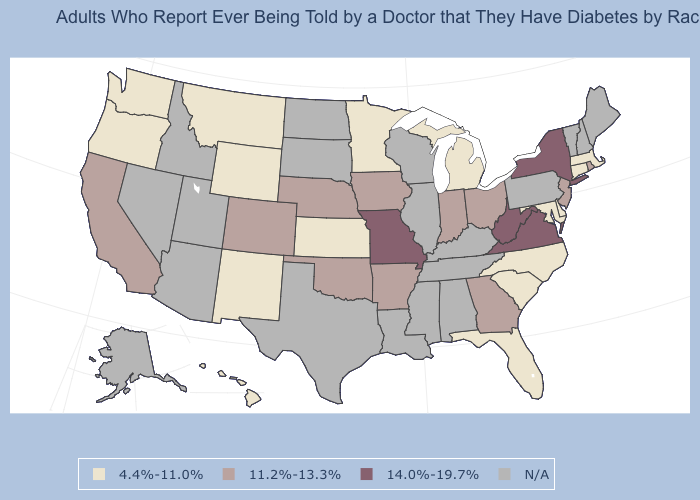What is the value of Connecticut?
Give a very brief answer. 4.4%-11.0%. Which states have the highest value in the USA?
Give a very brief answer. Missouri, New York, Virginia, West Virginia. What is the value of South Carolina?
Be succinct. 4.4%-11.0%. Among the states that border Florida , which have the highest value?
Write a very short answer. Georgia. What is the lowest value in states that border Washington?
Keep it brief. 4.4%-11.0%. Name the states that have a value in the range 14.0%-19.7%?
Concise answer only. Missouri, New York, Virginia, West Virginia. Does the first symbol in the legend represent the smallest category?
Quick response, please. Yes. Name the states that have a value in the range 4.4%-11.0%?
Quick response, please. Connecticut, Delaware, Florida, Hawaii, Kansas, Maryland, Massachusetts, Michigan, Minnesota, Montana, New Mexico, North Carolina, Oregon, South Carolina, Washington, Wyoming. What is the highest value in the USA?
Write a very short answer. 14.0%-19.7%. Among the states that border Wisconsin , which have the lowest value?
Quick response, please. Michigan, Minnesota. Name the states that have a value in the range N/A?
Concise answer only. Alabama, Alaska, Arizona, Idaho, Illinois, Kentucky, Louisiana, Maine, Mississippi, Nevada, New Hampshire, North Dakota, Pennsylvania, South Dakota, Tennessee, Texas, Utah, Vermont, Wisconsin. Which states have the highest value in the USA?
Keep it brief. Missouri, New York, Virginia, West Virginia. Does the first symbol in the legend represent the smallest category?
Keep it brief. Yes. 